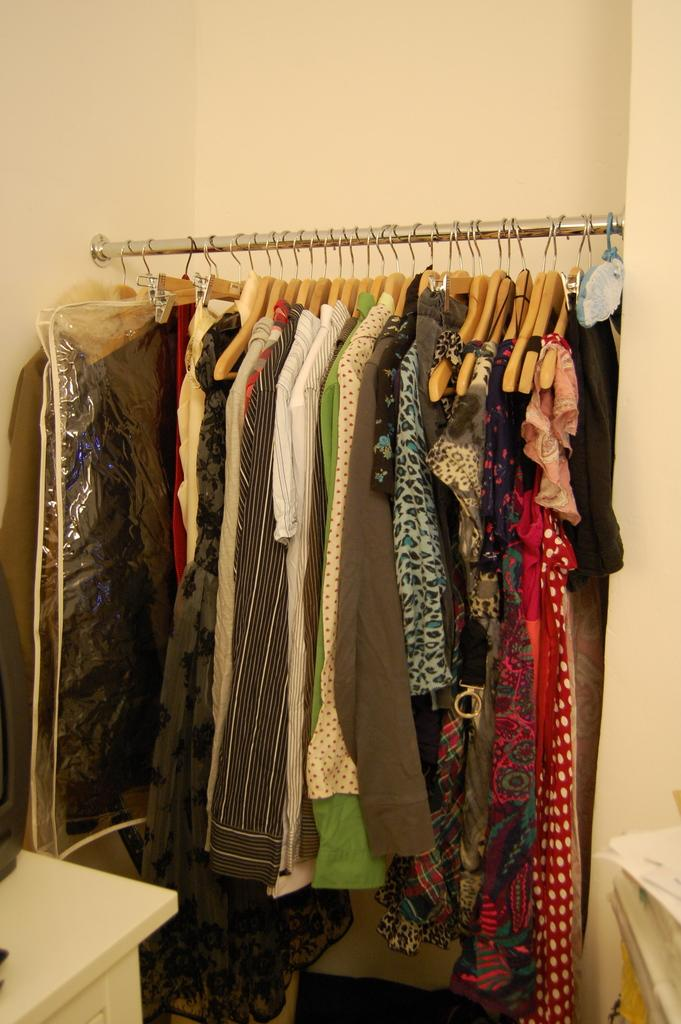What is attached to the pole in the image? There are clothes attached to a pole in the image. Can you describe any other objects or structures in the image? Yes, there is a table in the left bottom corner of the image. Where is the toothpaste located in the image? There is no toothpaste present in the image. What type of nut is being cracked on the stage in the image? There is no nut or stage present in the image. 